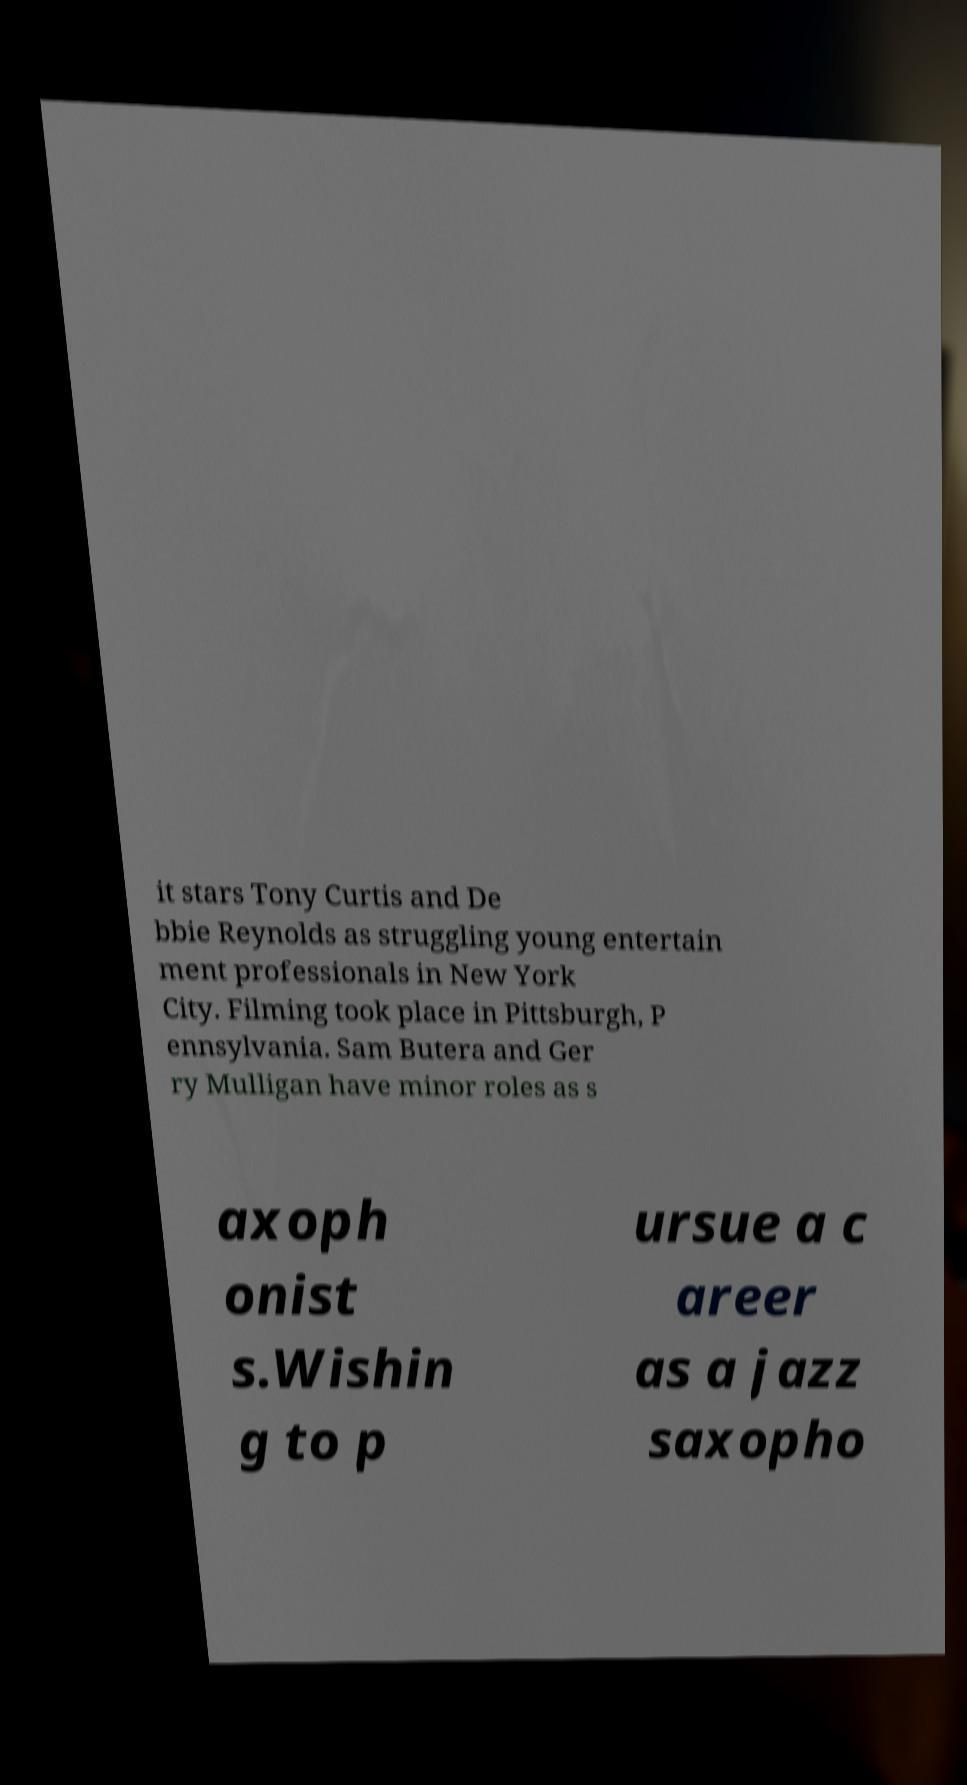Could you extract and type out the text from this image? it stars Tony Curtis and De bbie Reynolds as struggling young entertain ment professionals in New York City. Filming took place in Pittsburgh, P ennsylvania. Sam Butera and Ger ry Mulligan have minor roles as s axoph onist s.Wishin g to p ursue a c areer as a jazz saxopho 